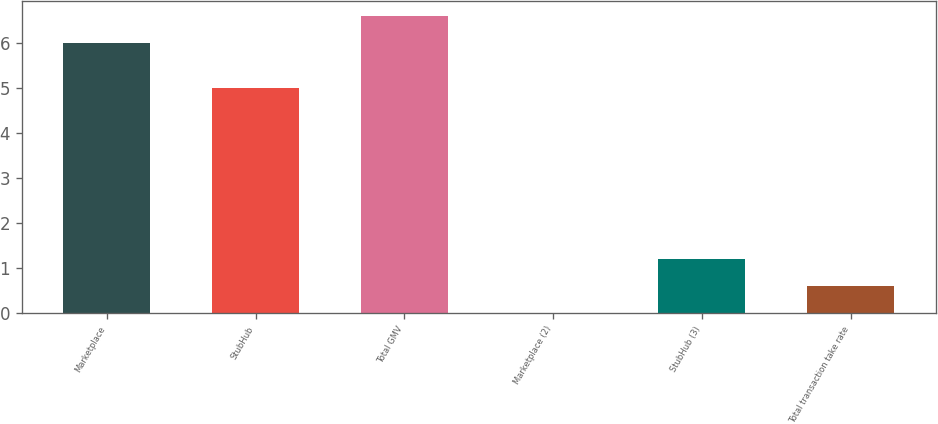Convert chart. <chart><loc_0><loc_0><loc_500><loc_500><bar_chart><fcel>Marketplace<fcel>StubHub<fcel>Total GMV<fcel>Marketplace (2)<fcel>StubHub (3)<fcel>Total transaction take rate<nl><fcel>6<fcel>5<fcel>6.6<fcel>0.01<fcel>1.21<fcel>0.61<nl></chart> 